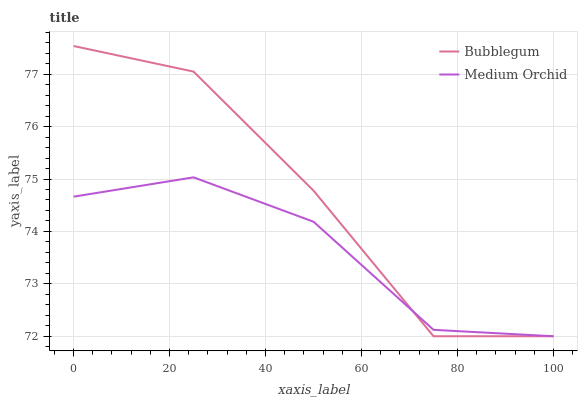Does Bubblegum have the minimum area under the curve?
Answer yes or no. No. Is Bubblegum the smoothest?
Answer yes or no. No. 